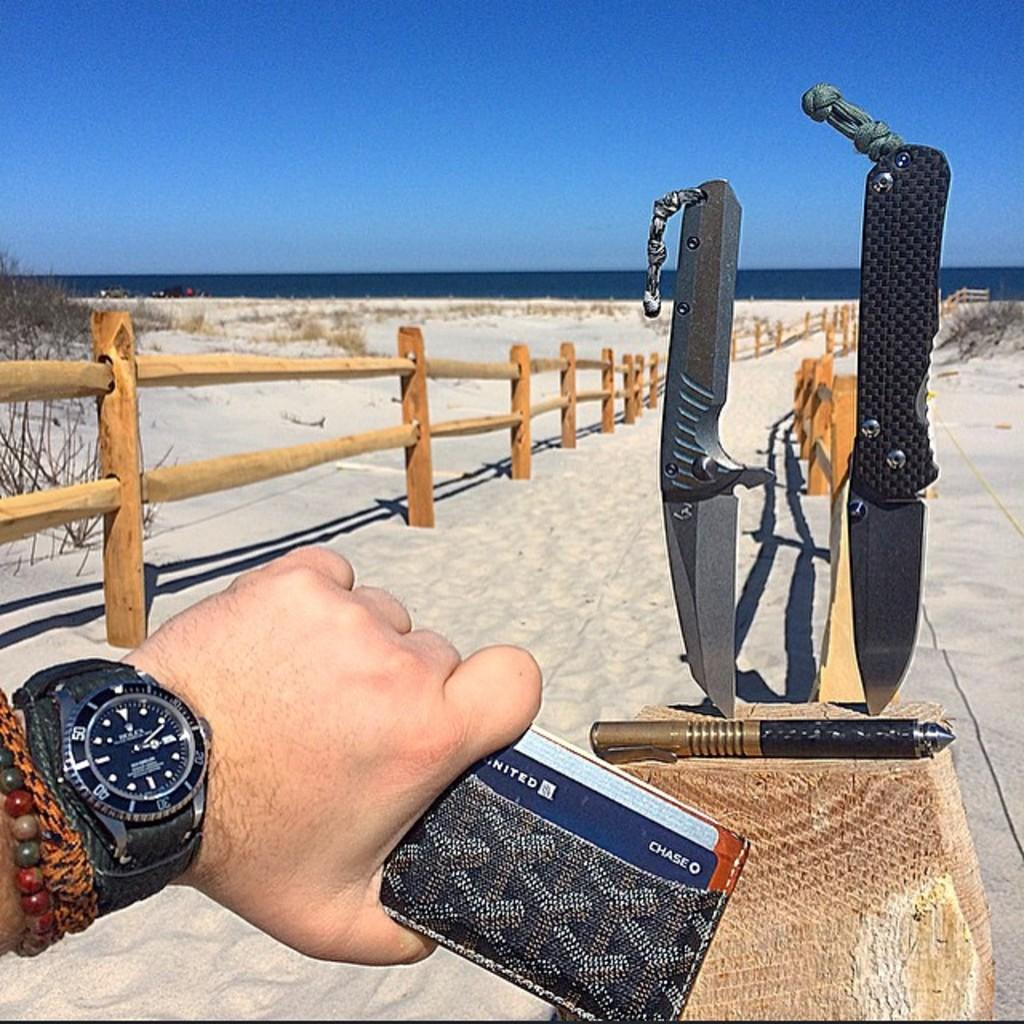<image>
Present a compact description of the photo's key features. Person holding a wallet with a blue CHASE card inside it. 